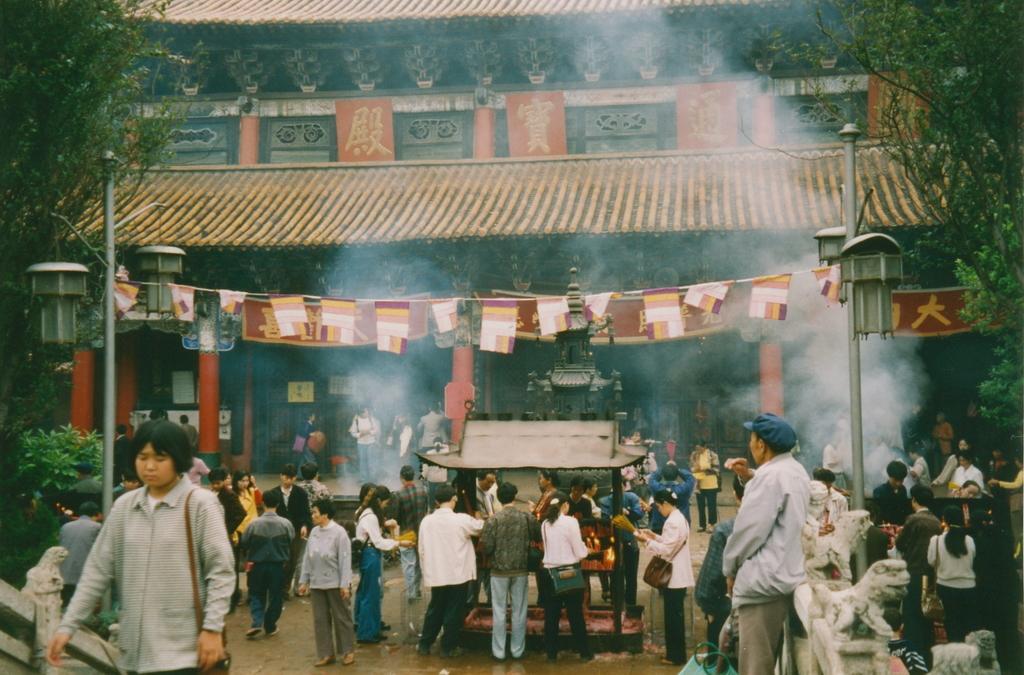Describe this image in one or two sentences. In this image we can see many people, few are standing and few are walking. In the background we can see an arch. Image also consists of trees, poles and a rope with flags. In the center there is roof for shelter. 